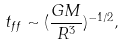Convert formula to latex. <formula><loc_0><loc_0><loc_500><loc_500>t _ { f f } \sim ( \frac { G M } { R ^ { 3 } } ) ^ { - 1 / 2 } ,</formula> 